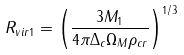<formula> <loc_0><loc_0><loc_500><loc_500>R _ { v i r 1 } = \left ( \frac { 3 M _ { 1 } } { 4 \pi \Delta _ { c } \Omega _ { M } \rho _ { c r } } \right ) ^ { 1 / 3 }</formula> 